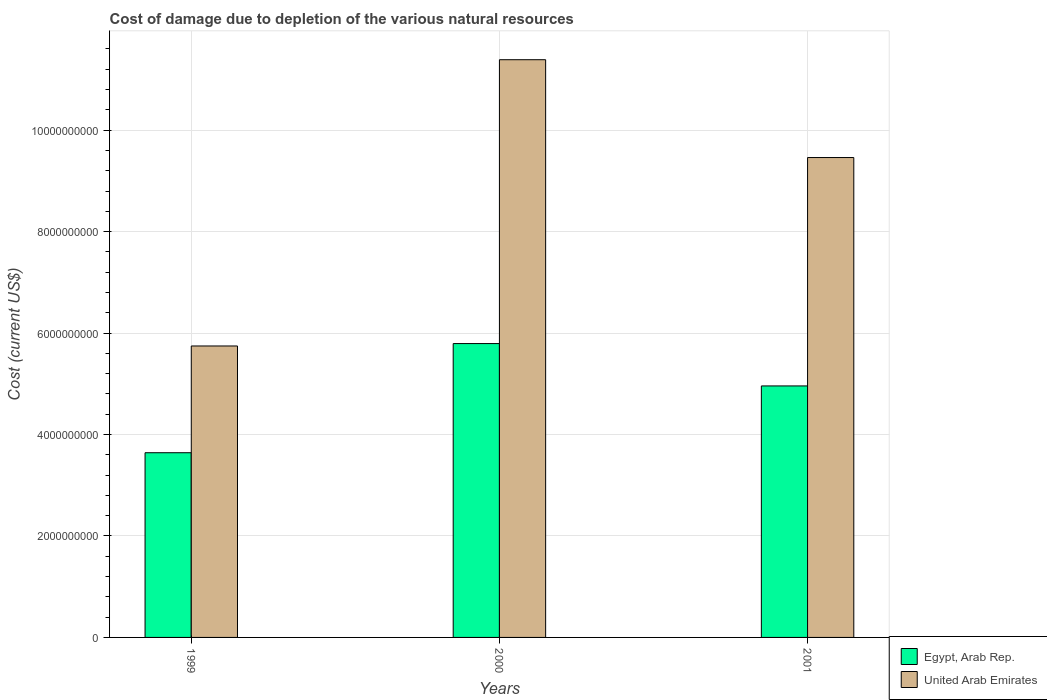How many different coloured bars are there?
Your answer should be compact. 2. Are the number of bars per tick equal to the number of legend labels?
Ensure brevity in your answer.  Yes. How many bars are there on the 2nd tick from the right?
Offer a terse response. 2. What is the label of the 2nd group of bars from the left?
Your response must be concise. 2000. What is the cost of damage caused due to the depletion of various natural resources in Egypt, Arab Rep. in 2000?
Your answer should be very brief. 5.79e+09. Across all years, what is the maximum cost of damage caused due to the depletion of various natural resources in United Arab Emirates?
Provide a short and direct response. 1.14e+1. Across all years, what is the minimum cost of damage caused due to the depletion of various natural resources in United Arab Emirates?
Make the answer very short. 5.75e+09. What is the total cost of damage caused due to the depletion of various natural resources in United Arab Emirates in the graph?
Provide a succinct answer. 2.66e+1. What is the difference between the cost of damage caused due to the depletion of various natural resources in United Arab Emirates in 1999 and that in 2001?
Provide a short and direct response. -3.71e+09. What is the difference between the cost of damage caused due to the depletion of various natural resources in United Arab Emirates in 2000 and the cost of damage caused due to the depletion of various natural resources in Egypt, Arab Rep. in 1999?
Offer a very short reply. 7.75e+09. What is the average cost of damage caused due to the depletion of various natural resources in United Arab Emirates per year?
Your answer should be compact. 8.86e+09. In the year 2001, what is the difference between the cost of damage caused due to the depletion of various natural resources in Egypt, Arab Rep. and cost of damage caused due to the depletion of various natural resources in United Arab Emirates?
Your answer should be compact. -4.50e+09. What is the ratio of the cost of damage caused due to the depletion of various natural resources in United Arab Emirates in 1999 to that in 2001?
Ensure brevity in your answer.  0.61. Is the difference between the cost of damage caused due to the depletion of various natural resources in Egypt, Arab Rep. in 1999 and 2001 greater than the difference between the cost of damage caused due to the depletion of various natural resources in United Arab Emirates in 1999 and 2001?
Your response must be concise. Yes. What is the difference between the highest and the second highest cost of damage caused due to the depletion of various natural resources in United Arab Emirates?
Make the answer very short. 1.93e+09. What is the difference between the highest and the lowest cost of damage caused due to the depletion of various natural resources in Egypt, Arab Rep.?
Your response must be concise. 2.15e+09. Is the sum of the cost of damage caused due to the depletion of various natural resources in Egypt, Arab Rep. in 2000 and 2001 greater than the maximum cost of damage caused due to the depletion of various natural resources in United Arab Emirates across all years?
Your answer should be very brief. No. What does the 1st bar from the left in 1999 represents?
Your answer should be very brief. Egypt, Arab Rep. What does the 1st bar from the right in 1999 represents?
Keep it short and to the point. United Arab Emirates. How many years are there in the graph?
Make the answer very short. 3. What is the difference between two consecutive major ticks on the Y-axis?
Keep it short and to the point. 2.00e+09. Are the values on the major ticks of Y-axis written in scientific E-notation?
Your answer should be compact. No. Does the graph contain grids?
Your answer should be very brief. Yes. Where does the legend appear in the graph?
Provide a succinct answer. Bottom right. What is the title of the graph?
Make the answer very short. Cost of damage due to depletion of the various natural resources. What is the label or title of the X-axis?
Give a very brief answer. Years. What is the label or title of the Y-axis?
Keep it short and to the point. Cost (current US$). What is the Cost (current US$) of Egypt, Arab Rep. in 1999?
Your response must be concise. 3.64e+09. What is the Cost (current US$) in United Arab Emirates in 1999?
Ensure brevity in your answer.  5.75e+09. What is the Cost (current US$) of Egypt, Arab Rep. in 2000?
Provide a succinct answer. 5.79e+09. What is the Cost (current US$) of United Arab Emirates in 2000?
Your answer should be compact. 1.14e+1. What is the Cost (current US$) of Egypt, Arab Rep. in 2001?
Make the answer very short. 4.96e+09. What is the Cost (current US$) in United Arab Emirates in 2001?
Your answer should be compact. 9.46e+09. Across all years, what is the maximum Cost (current US$) of Egypt, Arab Rep.?
Provide a short and direct response. 5.79e+09. Across all years, what is the maximum Cost (current US$) in United Arab Emirates?
Keep it short and to the point. 1.14e+1. Across all years, what is the minimum Cost (current US$) of Egypt, Arab Rep.?
Provide a succinct answer. 3.64e+09. Across all years, what is the minimum Cost (current US$) in United Arab Emirates?
Offer a terse response. 5.75e+09. What is the total Cost (current US$) in Egypt, Arab Rep. in the graph?
Keep it short and to the point. 1.44e+1. What is the total Cost (current US$) of United Arab Emirates in the graph?
Your response must be concise. 2.66e+1. What is the difference between the Cost (current US$) in Egypt, Arab Rep. in 1999 and that in 2000?
Provide a succinct answer. -2.15e+09. What is the difference between the Cost (current US$) in United Arab Emirates in 1999 and that in 2000?
Provide a short and direct response. -5.64e+09. What is the difference between the Cost (current US$) of Egypt, Arab Rep. in 1999 and that in 2001?
Ensure brevity in your answer.  -1.32e+09. What is the difference between the Cost (current US$) of United Arab Emirates in 1999 and that in 2001?
Ensure brevity in your answer.  -3.71e+09. What is the difference between the Cost (current US$) in Egypt, Arab Rep. in 2000 and that in 2001?
Your answer should be very brief. 8.35e+08. What is the difference between the Cost (current US$) of United Arab Emirates in 2000 and that in 2001?
Give a very brief answer. 1.93e+09. What is the difference between the Cost (current US$) in Egypt, Arab Rep. in 1999 and the Cost (current US$) in United Arab Emirates in 2000?
Your answer should be compact. -7.75e+09. What is the difference between the Cost (current US$) of Egypt, Arab Rep. in 1999 and the Cost (current US$) of United Arab Emirates in 2001?
Provide a succinct answer. -5.82e+09. What is the difference between the Cost (current US$) of Egypt, Arab Rep. in 2000 and the Cost (current US$) of United Arab Emirates in 2001?
Provide a succinct answer. -3.67e+09. What is the average Cost (current US$) of Egypt, Arab Rep. per year?
Offer a terse response. 4.80e+09. What is the average Cost (current US$) of United Arab Emirates per year?
Offer a terse response. 8.86e+09. In the year 1999, what is the difference between the Cost (current US$) of Egypt, Arab Rep. and Cost (current US$) of United Arab Emirates?
Ensure brevity in your answer.  -2.10e+09. In the year 2000, what is the difference between the Cost (current US$) in Egypt, Arab Rep. and Cost (current US$) in United Arab Emirates?
Your answer should be compact. -5.60e+09. In the year 2001, what is the difference between the Cost (current US$) of Egypt, Arab Rep. and Cost (current US$) of United Arab Emirates?
Make the answer very short. -4.50e+09. What is the ratio of the Cost (current US$) of Egypt, Arab Rep. in 1999 to that in 2000?
Your response must be concise. 0.63. What is the ratio of the Cost (current US$) of United Arab Emirates in 1999 to that in 2000?
Offer a terse response. 0.5. What is the ratio of the Cost (current US$) of Egypt, Arab Rep. in 1999 to that in 2001?
Offer a very short reply. 0.73. What is the ratio of the Cost (current US$) in United Arab Emirates in 1999 to that in 2001?
Make the answer very short. 0.61. What is the ratio of the Cost (current US$) of Egypt, Arab Rep. in 2000 to that in 2001?
Offer a terse response. 1.17. What is the ratio of the Cost (current US$) in United Arab Emirates in 2000 to that in 2001?
Offer a very short reply. 1.2. What is the difference between the highest and the second highest Cost (current US$) of Egypt, Arab Rep.?
Give a very brief answer. 8.35e+08. What is the difference between the highest and the second highest Cost (current US$) in United Arab Emirates?
Your answer should be compact. 1.93e+09. What is the difference between the highest and the lowest Cost (current US$) in Egypt, Arab Rep.?
Keep it short and to the point. 2.15e+09. What is the difference between the highest and the lowest Cost (current US$) of United Arab Emirates?
Your answer should be compact. 5.64e+09. 